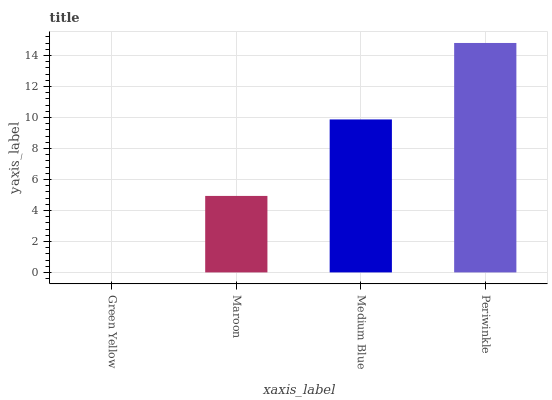Is Green Yellow the minimum?
Answer yes or no. Yes. Is Periwinkle the maximum?
Answer yes or no. Yes. Is Maroon the minimum?
Answer yes or no. No. Is Maroon the maximum?
Answer yes or no. No. Is Maroon greater than Green Yellow?
Answer yes or no. Yes. Is Green Yellow less than Maroon?
Answer yes or no. Yes. Is Green Yellow greater than Maroon?
Answer yes or no. No. Is Maroon less than Green Yellow?
Answer yes or no. No. Is Medium Blue the high median?
Answer yes or no. Yes. Is Maroon the low median?
Answer yes or no. Yes. Is Maroon the high median?
Answer yes or no. No. Is Periwinkle the low median?
Answer yes or no. No. 